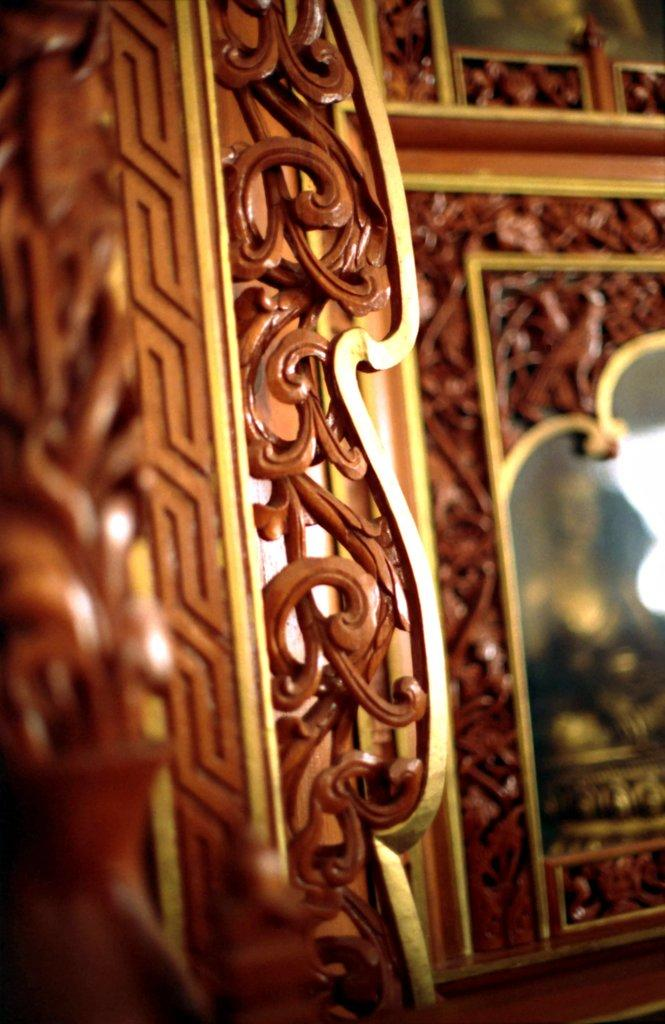What is a prominent feature in the image? There is a door in the image. Can you describe the door in more detail? The door has a design on it. What else can be seen on the right side of the image? There is a mirror on the right side of the image. How is the mirror decorated? The mirror has a design around it. How is the quilt distributed among the girls in the image? There are no girls or quilts present in the image; it only features a door and a mirror. 